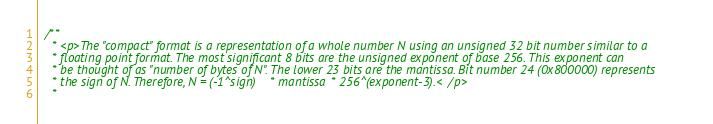Convert code to text. <code><loc_0><loc_0><loc_500><loc_500><_Scala_>  /**
    * <p>The "compact" format is a representation of a whole number N using an unsigned 32 bit number similar to a
    * floating point format. The most significant 8 bits are the unsigned exponent of base 256. This exponent can
    * be thought of as "number of bytes of N". The lower 23 bits are the mantissa. Bit number 24 (0x800000) represents
    * the sign of N. Therefore, N = (-1^sign) * mantissa * 256^(exponent-3).</p>
    *</code> 